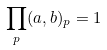Convert formula to latex. <formula><loc_0><loc_0><loc_500><loc_500>\prod _ { p } ( a , b ) _ { p } = 1</formula> 